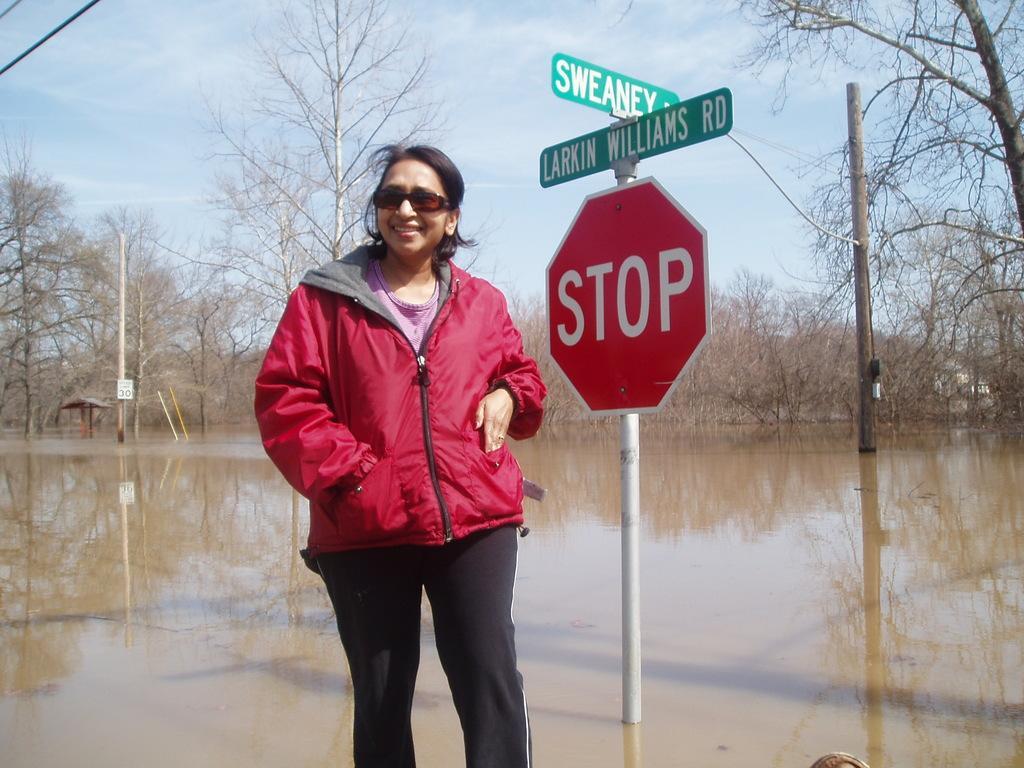Please provide a concise description of this image. In the picture we can see a woman standing with a red color jacket and wearing a goggles and she is smiling and beside her we can see a pole with stop board and some direction boards on it and behind it, we can see water and some trees and far away also we can see trees and sky with some clouds. 